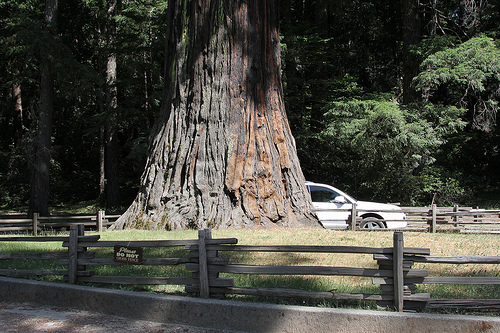<image>
Is there a car behind the tree? Yes. From this viewpoint, the car is positioned behind the tree, with the tree partially or fully occluding the car. Is the tire next to the tree? Yes. The tire is positioned adjacent to the tree, located nearby in the same general area. 